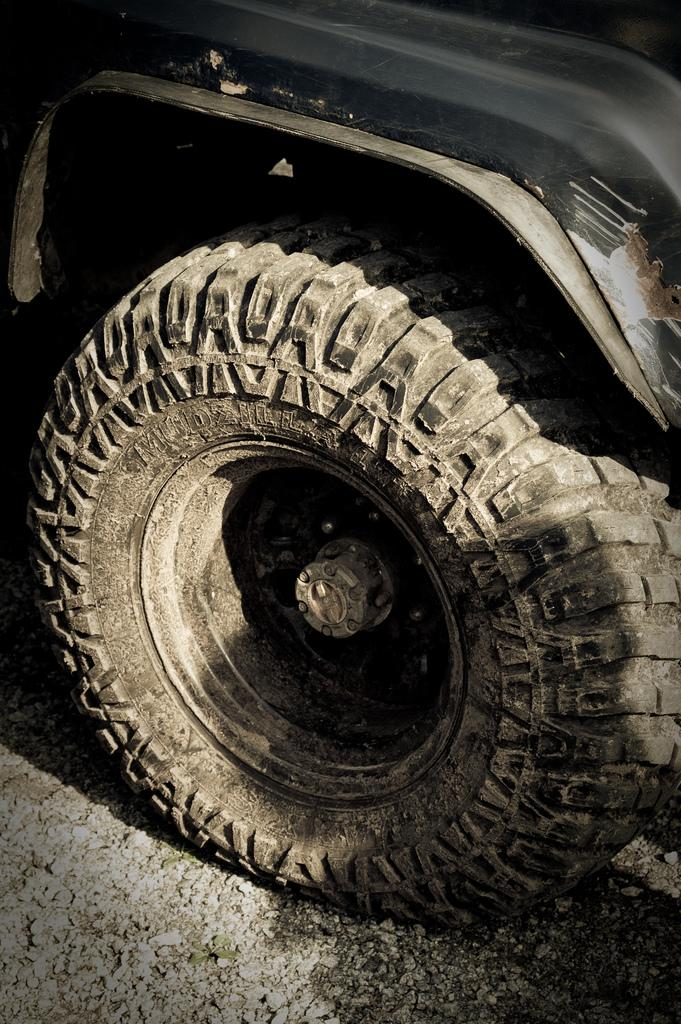What is located in the foreground of the image? There is a vehicle and a tire in the foreground of the image. What type of surface can be seen at the bottom of the image? There is a road visible at the bottom of the image. What type of pet can be seen in the store in the image? There is no store or pet present in the image. 